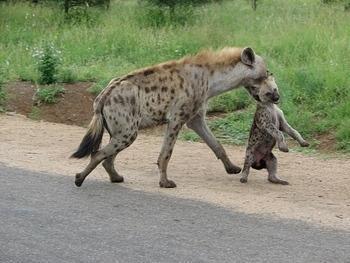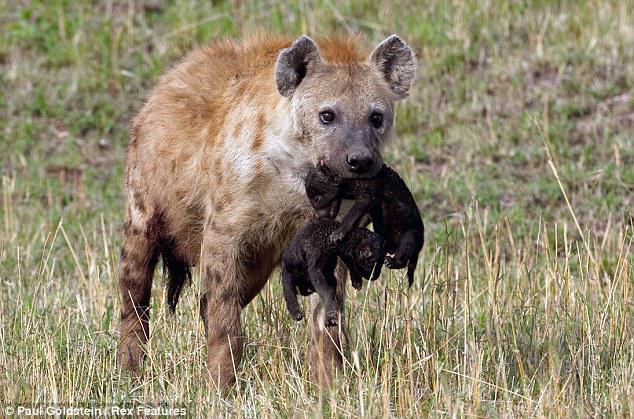The first image is the image on the left, the second image is the image on the right. For the images displayed, is the sentence "Each image shows one adult hyena carrying at least one pup in its mouth." factually correct? Answer yes or no. Yes. The first image is the image on the left, the second image is the image on the right. For the images shown, is this caption "In at least one image there is a single tan and black spotted hyena walking right holding a small pup in its mouth." true? Answer yes or no. Yes. 